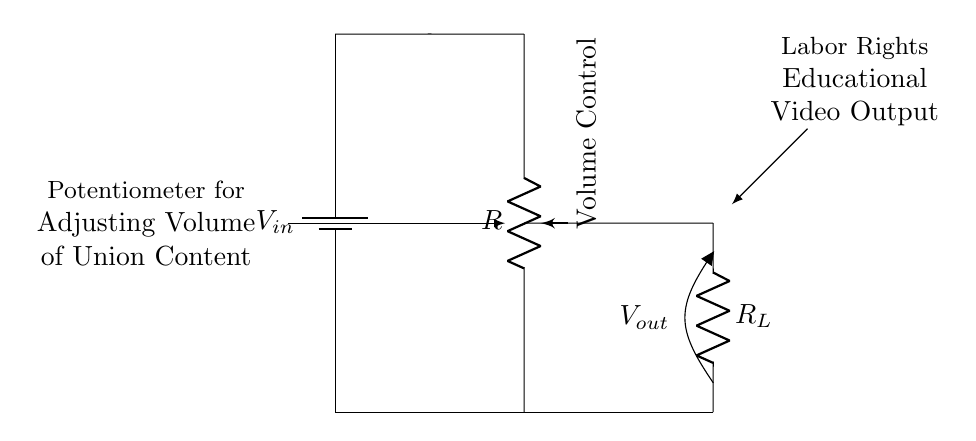What is the function of the potentiometer in this circuit? The potentiometer acts as a variable resistor, allowing the user to adjust the resistance in order to control the output voltage, which in this case adjusts the volume of the audio.
Answer: Volume control What does \(V_{out}\) represent? \(V_{out}\) represents the output voltage across the load resistor \(R_L\), which is used to drive the volume of the educational video content.
Answer: Output voltage What is the total voltage \(V_{in}\) applied in this circuit? The diagram does not specify a value for \(V_{in}\), but it typically represents the source voltage; it could be standard values like 5V, 9V, or another rating used in similar circuits.
Answer: Not specified How many resistors are present in the circuit? There are two resistors in the circuit: one is the potentiometer and the other is the load resistor \(R_L\).
Answer: Two resistors What type of circuit is this? This is a voltage divider circuit, which is used to create a lower output voltage \(V_{out}\) from the input voltage \(V_{in}\).
Answer: Voltage divider What is the purpose of the load resistor \(R_L\)? The load resistor \(R_L\) is used to draw current and convert the voltage from the divider into a usable level for audio output.
Answer: Current draw What happens to \(V_{out}\) when the potentiometer is adjusted? Adjusting the potentiometer changes its resistance, which in turn alters the division of voltage between the two resistors, thus changing \(V_{out}\) to increase or decrease the volume level.
Answer: Changes with adjustment 